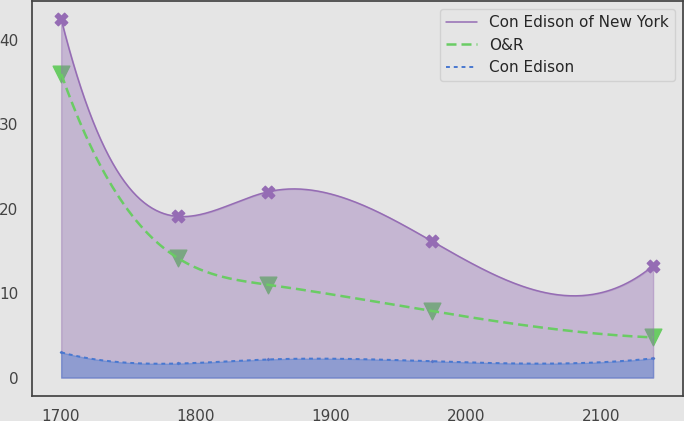<chart> <loc_0><loc_0><loc_500><loc_500><line_chart><ecel><fcel>Con Edison of New York<fcel>O&R<fcel>Con Edison<nl><fcel>1700.43<fcel>42.46<fcel>35.99<fcel>2.99<nl><fcel>1787.15<fcel>19.09<fcel>14.12<fcel>1.67<nl><fcel>1853.48<fcel>22.01<fcel>11<fcel>2.15<nl><fcel>1974.7<fcel>16.17<fcel>7.88<fcel>1.94<nl><fcel>2138.48<fcel>13.25<fcel>4.76<fcel>2.28<nl></chart> 